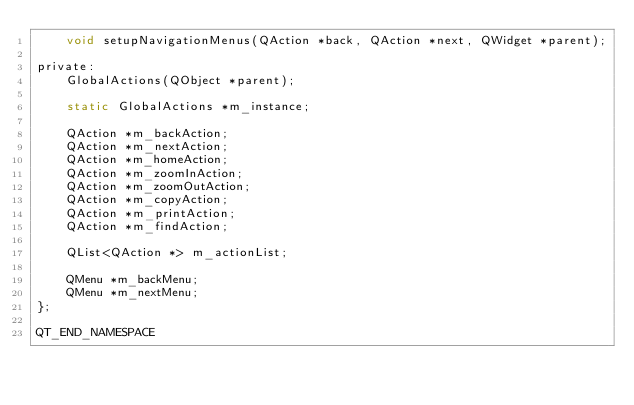<code> <loc_0><loc_0><loc_500><loc_500><_C_>    void setupNavigationMenus(QAction *back, QAction *next, QWidget *parent);

private:
    GlobalActions(QObject *parent);

    static GlobalActions *m_instance;

    QAction *m_backAction;
    QAction *m_nextAction;
    QAction *m_homeAction;
    QAction *m_zoomInAction;
    QAction *m_zoomOutAction;
    QAction *m_copyAction;
    QAction *m_printAction;
    QAction *m_findAction;

    QList<QAction *> m_actionList;

    QMenu *m_backMenu;
    QMenu *m_nextMenu;
};

QT_END_NAMESPACE
</code> 